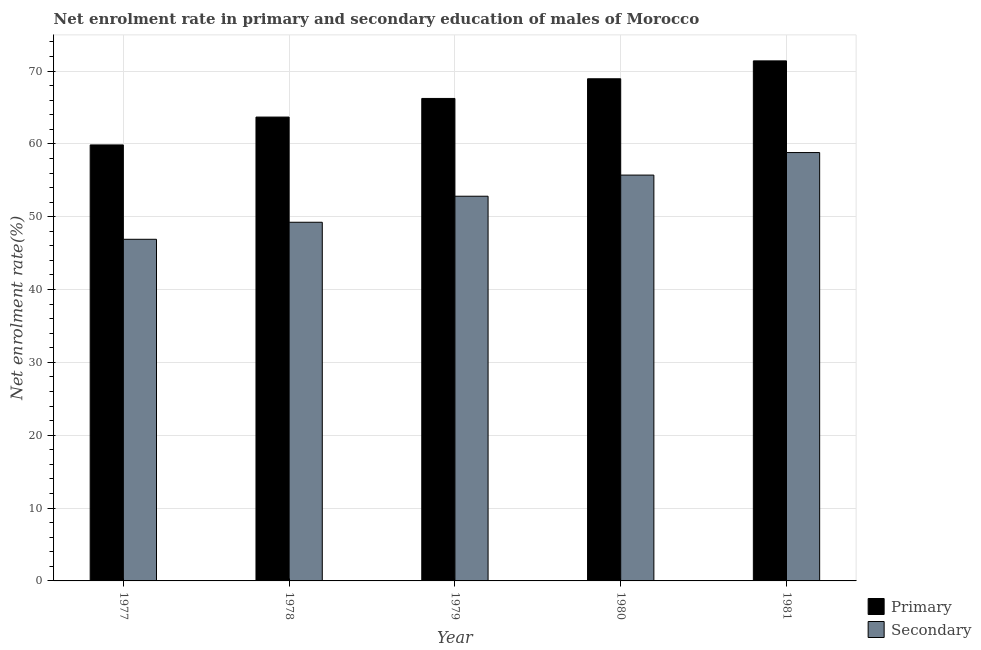Are the number of bars on each tick of the X-axis equal?
Ensure brevity in your answer.  Yes. In how many cases, is the number of bars for a given year not equal to the number of legend labels?
Ensure brevity in your answer.  0. What is the enrollment rate in primary education in 1980?
Provide a short and direct response. 68.94. Across all years, what is the maximum enrollment rate in secondary education?
Give a very brief answer. 58.81. Across all years, what is the minimum enrollment rate in secondary education?
Offer a terse response. 46.9. In which year was the enrollment rate in primary education minimum?
Offer a terse response. 1977. What is the total enrollment rate in secondary education in the graph?
Your answer should be compact. 263.48. What is the difference between the enrollment rate in primary education in 1978 and that in 1981?
Your response must be concise. -7.71. What is the difference between the enrollment rate in primary education in 1978 and the enrollment rate in secondary education in 1977?
Offer a terse response. 3.82. What is the average enrollment rate in primary education per year?
Keep it short and to the point. 66.02. In how many years, is the enrollment rate in primary education greater than 58 %?
Give a very brief answer. 5. What is the ratio of the enrollment rate in primary education in 1980 to that in 1981?
Provide a short and direct response. 0.97. Is the enrollment rate in secondary education in 1977 less than that in 1981?
Your response must be concise. Yes. Is the difference between the enrollment rate in primary education in 1979 and 1980 greater than the difference between the enrollment rate in secondary education in 1979 and 1980?
Keep it short and to the point. No. What is the difference between the highest and the second highest enrollment rate in secondary education?
Provide a short and direct response. 3.09. What is the difference between the highest and the lowest enrollment rate in secondary education?
Offer a very short reply. 11.91. In how many years, is the enrollment rate in primary education greater than the average enrollment rate in primary education taken over all years?
Keep it short and to the point. 3. What does the 1st bar from the left in 1979 represents?
Your answer should be compact. Primary. What does the 1st bar from the right in 1981 represents?
Provide a short and direct response. Secondary. How many bars are there?
Give a very brief answer. 10. Are the values on the major ticks of Y-axis written in scientific E-notation?
Offer a terse response. No. What is the title of the graph?
Offer a terse response. Net enrolment rate in primary and secondary education of males of Morocco. Does "Gasoline" appear as one of the legend labels in the graph?
Provide a succinct answer. No. What is the label or title of the Y-axis?
Your response must be concise. Net enrolment rate(%). What is the Net enrolment rate(%) in Primary in 1977?
Your answer should be compact. 59.86. What is the Net enrolment rate(%) in Secondary in 1977?
Ensure brevity in your answer.  46.9. What is the Net enrolment rate(%) in Primary in 1978?
Keep it short and to the point. 63.68. What is the Net enrolment rate(%) in Secondary in 1978?
Provide a succinct answer. 49.24. What is the Net enrolment rate(%) in Primary in 1979?
Your answer should be compact. 66.24. What is the Net enrolment rate(%) in Secondary in 1979?
Offer a very short reply. 52.81. What is the Net enrolment rate(%) in Primary in 1980?
Make the answer very short. 68.94. What is the Net enrolment rate(%) of Secondary in 1980?
Offer a terse response. 55.72. What is the Net enrolment rate(%) of Primary in 1981?
Ensure brevity in your answer.  71.39. What is the Net enrolment rate(%) of Secondary in 1981?
Offer a very short reply. 58.81. Across all years, what is the maximum Net enrolment rate(%) of Primary?
Make the answer very short. 71.39. Across all years, what is the maximum Net enrolment rate(%) in Secondary?
Make the answer very short. 58.81. Across all years, what is the minimum Net enrolment rate(%) of Primary?
Offer a terse response. 59.86. Across all years, what is the minimum Net enrolment rate(%) of Secondary?
Keep it short and to the point. 46.9. What is the total Net enrolment rate(%) of Primary in the graph?
Your answer should be compact. 330.1. What is the total Net enrolment rate(%) in Secondary in the graph?
Make the answer very short. 263.48. What is the difference between the Net enrolment rate(%) in Primary in 1977 and that in 1978?
Your response must be concise. -3.82. What is the difference between the Net enrolment rate(%) of Secondary in 1977 and that in 1978?
Offer a very short reply. -2.34. What is the difference between the Net enrolment rate(%) in Primary in 1977 and that in 1979?
Provide a succinct answer. -6.38. What is the difference between the Net enrolment rate(%) of Secondary in 1977 and that in 1979?
Keep it short and to the point. -5.91. What is the difference between the Net enrolment rate(%) in Primary in 1977 and that in 1980?
Your response must be concise. -9.08. What is the difference between the Net enrolment rate(%) in Secondary in 1977 and that in 1980?
Offer a very short reply. -8.81. What is the difference between the Net enrolment rate(%) of Primary in 1977 and that in 1981?
Give a very brief answer. -11.54. What is the difference between the Net enrolment rate(%) in Secondary in 1977 and that in 1981?
Give a very brief answer. -11.91. What is the difference between the Net enrolment rate(%) of Primary in 1978 and that in 1979?
Offer a terse response. -2.56. What is the difference between the Net enrolment rate(%) of Secondary in 1978 and that in 1979?
Offer a very short reply. -3.57. What is the difference between the Net enrolment rate(%) in Primary in 1978 and that in 1980?
Offer a very short reply. -5.26. What is the difference between the Net enrolment rate(%) in Secondary in 1978 and that in 1980?
Provide a succinct answer. -6.48. What is the difference between the Net enrolment rate(%) in Primary in 1978 and that in 1981?
Give a very brief answer. -7.71. What is the difference between the Net enrolment rate(%) of Secondary in 1978 and that in 1981?
Your answer should be very brief. -9.57. What is the difference between the Net enrolment rate(%) in Primary in 1979 and that in 1980?
Provide a succinct answer. -2.7. What is the difference between the Net enrolment rate(%) of Secondary in 1979 and that in 1980?
Provide a succinct answer. -2.9. What is the difference between the Net enrolment rate(%) of Primary in 1979 and that in 1981?
Offer a terse response. -5.16. What is the difference between the Net enrolment rate(%) of Secondary in 1979 and that in 1981?
Provide a succinct answer. -5.99. What is the difference between the Net enrolment rate(%) of Primary in 1980 and that in 1981?
Offer a terse response. -2.46. What is the difference between the Net enrolment rate(%) of Secondary in 1980 and that in 1981?
Provide a short and direct response. -3.09. What is the difference between the Net enrolment rate(%) in Primary in 1977 and the Net enrolment rate(%) in Secondary in 1978?
Your answer should be very brief. 10.62. What is the difference between the Net enrolment rate(%) in Primary in 1977 and the Net enrolment rate(%) in Secondary in 1979?
Your answer should be compact. 7.04. What is the difference between the Net enrolment rate(%) of Primary in 1977 and the Net enrolment rate(%) of Secondary in 1980?
Keep it short and to the point. 4.14. What is the difference between the Net enrolment rate(%) of Primary in 1977 and the Net enrolment rate(%) of Secondary in 1981?
Provide a short and direct response. 1.05. What is the difference between the Net enrolment rate(%) in Primary in 1978 and the Net enrolment rate(%) in Secondary in 1979?
Keep it short and to the point. 10.87. What is the difference between the Net enrolment rate(%) of Primary in 1978 and the Net enrolment rate(%) of Secondary in 1980?
Your response must be concise. 7.96. What is the difference between the Net enrolment rate(%) of Primary in 1978 and the Net enrolment rate(%) of Secondary in 1981?
Make the answer very short. 4.87. What is the difference between the Net enrolment rate(%) in Primary in 1979 and the Net enrolment rate(%) in Secondary in 1980?
Your answer should be compact. 10.52. What is the difference between the Net enrolment rate(%) in Primary in 1979 and the Net enrolment rate(%) in Secondary in 1981?
Your answer should be very brief. 7.43. What is the difference between the Net enrolment rate(%) in Primary in 1980 and the Net enrolment rate(%) in Secondary in 1981?
Offer a terse response. 10.13. What is the average Net enrolment rate(%) of Primary per year?
Provide a short and direct response. 66.02. What is the average Net enrolment rate(%) of Secondary per year?
Provide a succinct answer. 52.7. In the year 1977, what is the difference between the Net enrolment rate(%) in Primary and Net enrolment rate(%) in Secondary?
Make the answer very short. 12.95. In the year 1978, what is the difference between the Net enrolment rate(%) in Primary and Net enrolment rate(%) in Secondary?
Keep it short and to the point. 14.44. In the year 1979, what is the difference between the Net enrolment rate(%) of Primary and Net enrolment rate(%) of Secondary?
Your answer should be very brief. 13.42. In the year 1980, what is the difference between the Net enrolment rate(%) of Primary and Net enrolment rate(%) of Secondary?
Provide a succinct answer. 13.22. In the year 1981, what is the difference between the Net enrolment rate(%) in Primary and Net enrolment rate(%) in Secondary?
Give a very brief answer. 12.59. What is the ratio of the Net enrolment rate(%) of Secondary in 1977 to that in 1978?
Offer a very short reply. 0.95. What is the ratio of the Net enrolment rate(%) of Primary in 1977 to that in 1979?
Keep it short and to the point. 0.9. What is the ratio of the Net enrolment rate(%) in Secondary in 1977 to that in 1979?
Provide a succinct answer. 0.89. What is the ratio of the Net enrolment rate(%) of Primary in 1977 to that in 1980?
Ensure brevity in your answer.  0.87. What is the ratio of the Net enrolment rate(%) in Secondary in 1977 to that in 1980?
Your answer should be compact. 0.84. What is the ratio of the Net enrolment rate(%) in Primary in 1977 to that in 1981?
Ensure brevity in your answer.  0.84. What is the ratio of the Net enrolment rate(%) in Secondary in 1977 to that in 1981?
Provide a succinct answer. 0.8. What is the ratio of the Net enrolment rate(%) of Primary in 1978 to that in 1979?
Make the answer very short. 0.96. What is the ratio of the Net enrolment rate(%) of Secondary in 1978 to that in 1979?
Keep it short and to the point. 0.93. What is the ratio of the Net enrolment rate(%) in Primary in 1978 to that in 1980?
Keep it short and to the point. 0.92. What is the ratio of the Net enrolment rate(%) of Secondary in 1978 to that in 1980?
Provide a succinct answer. 0.88. What is the ratio of the Net enrolment rate(%) of Primary in 1978 to that in 1981?
Provide a short and direct response. 0.89. What is the ratio of the Net enrolment rate(%) of Secondary in 1978 to that in 1981?
Your answer should be compact. 0.84. What is the ratio of the Net enrolment rate(%) in Primary in 1979 to that in 1980?
Your answer should be very brief. 0.96. What is the ratio of the Net enrolment rate(%) in Secondary in 1979 to that in 1980?
Offer a terse response. 0.95. What is the ratio of the Net enrolment rate(%) in Primary in 1979 to that in 1981?
Your response must be concise. 0.93. What is the ratio of the Net enrolment rate(%) in Secondary in 1979 to that in 1981?
Keep it short and to the point. 0.9. What is the ratio of the Net enrolment rate(%) in Primary in 1980 to that in 1981?
Your answer should be very brief. 0.97. What is the difference between the highest and the second highest Net enrolment rate(%) in Primary?
Ensure brevity in your answer.  2.46. What is the difference between the highest and the second highest Net enrolment rate(%) in Secondary?
Give a very brief answer. 3.09. What is the difference between the highest and the lowest Net enrolment rate(%) of Primary?
Your answer should be compact. 11.54. What is the difference between the highest and the lowest Net enrolment rate(%) in Secondary?
Offer a terse response. 11.91. 